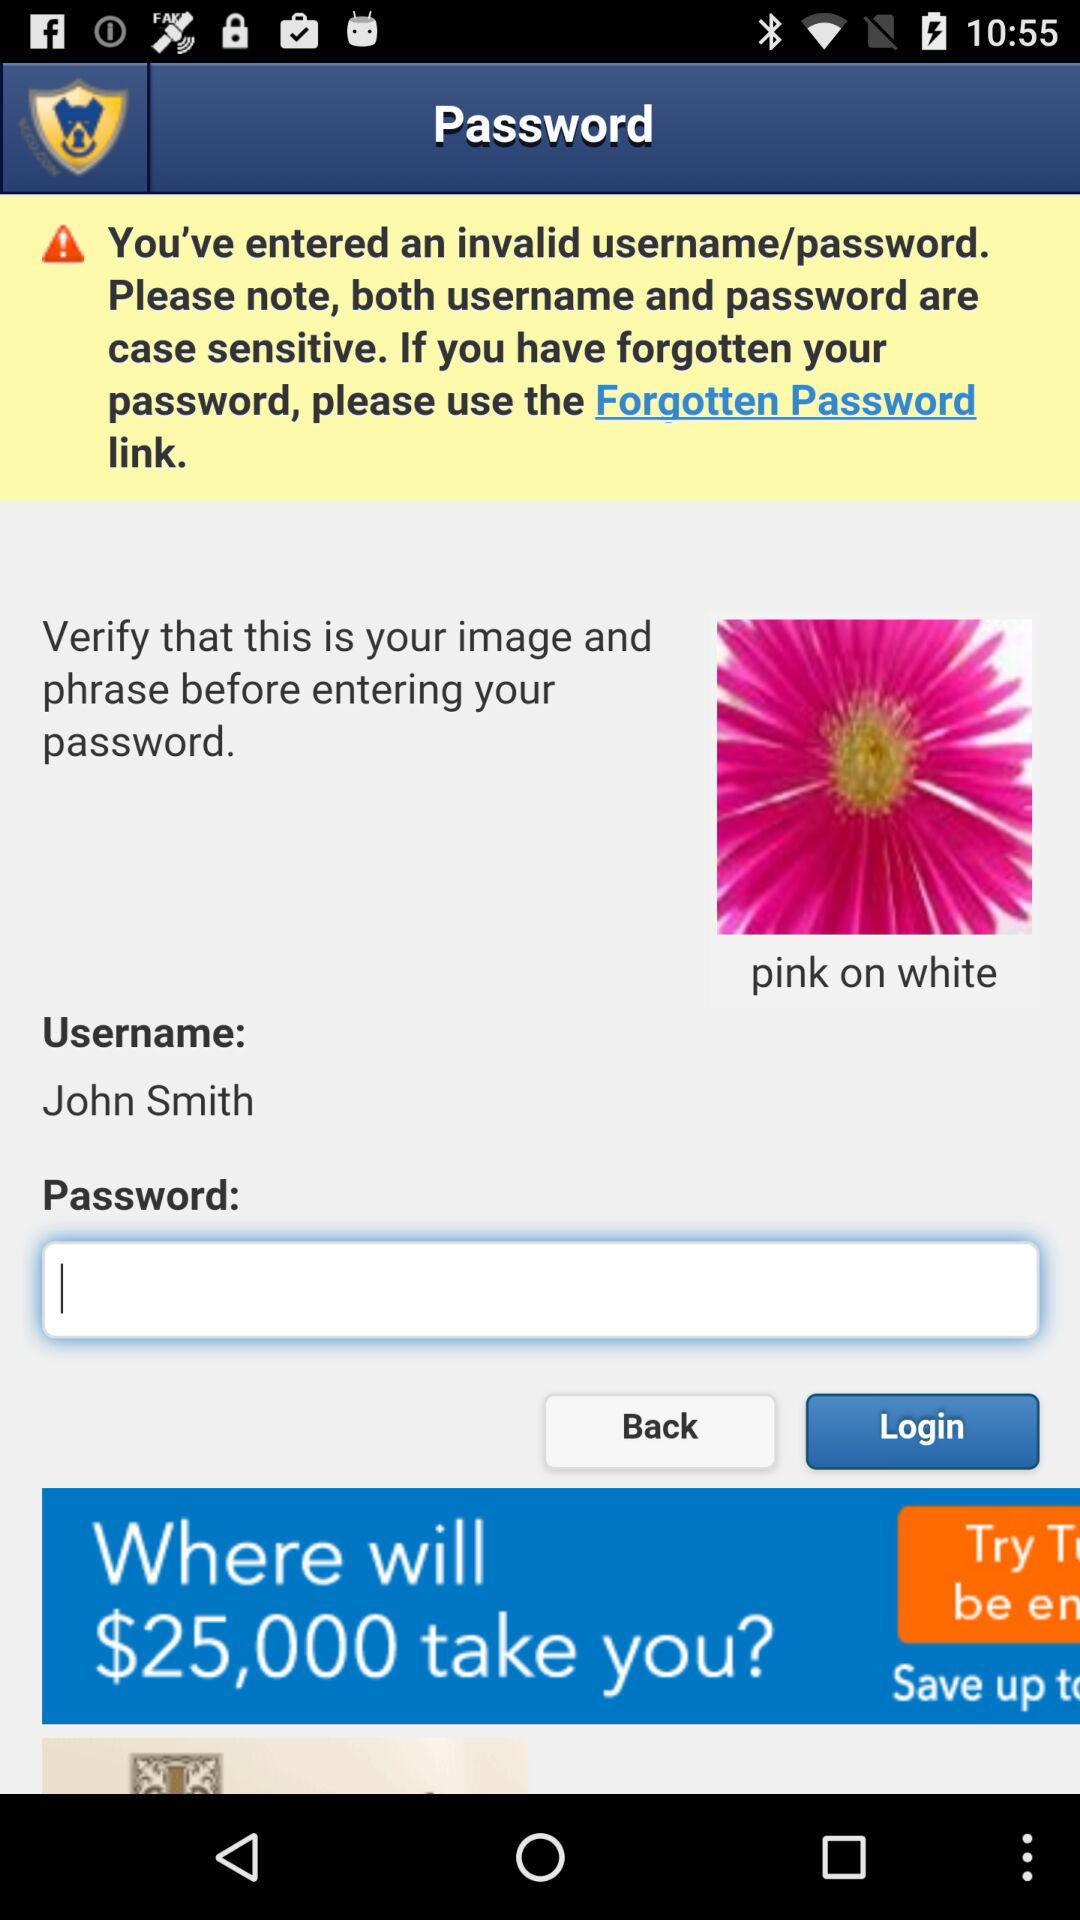What is the user name? The user name is John Smith. 